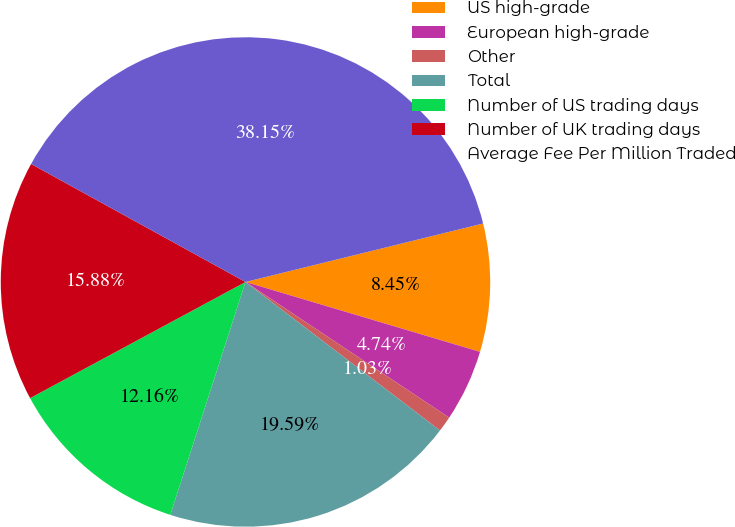Convert chart to OTSL. <chart><loc_0><loc_0><loc_500><loc_500><pie_chart><fcel>US high-grade<fcel>European high-grade<fcel>Other<fcel>Total<fcel>Number of US trading days<fcel>Number of UK trading days<fcel>Average Fee Per Million Traded<nl><fcel>8.45%<fcel>4.74%<fcel>1.03%<fcel>19.59%<fcel>12.16%<fcel>15.88%<fcel>38.15%<nl></chart> 